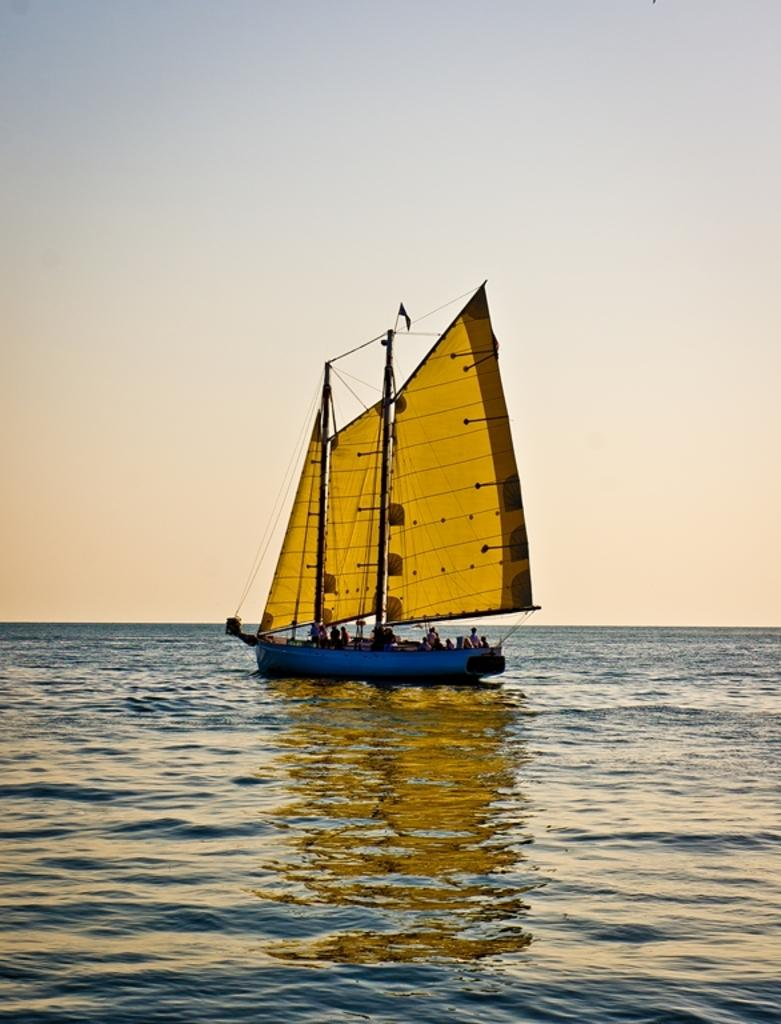What are the people in the image doing? The people in the image are on boats. What is the primary setting of the image? There is water visible in the image. What else can be seen in the background of the image? There is sky visible in the image. What type of territory is being claimed by the actor in the image? There is no actor present in the image, and no territory is being claimed. 